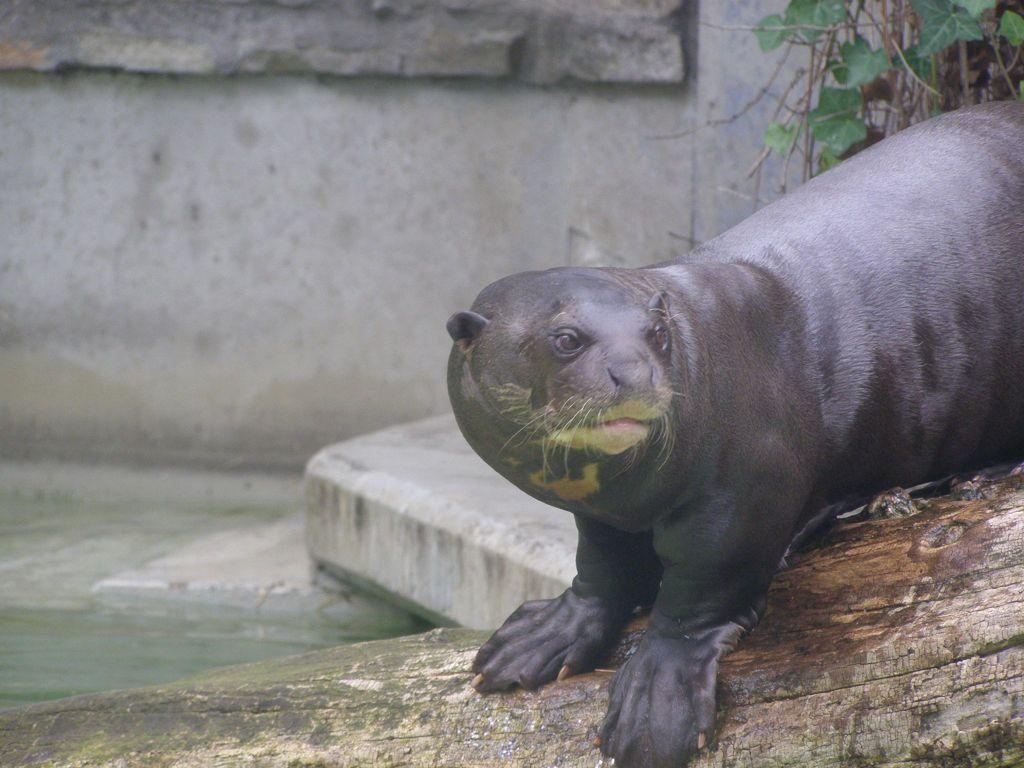What type of animal is in the image? The animal in the image resembles a seal. What color is the animal? The animal is black in color. What else can be seen in the image besides the animal? There is a plant visible at the top of the image. What type of hydrant is visible in the image? There is no hydrant present in the image. How many toes does the animal have in the image? The image does not show the animal's toes, so it cannot be determined from the image. 